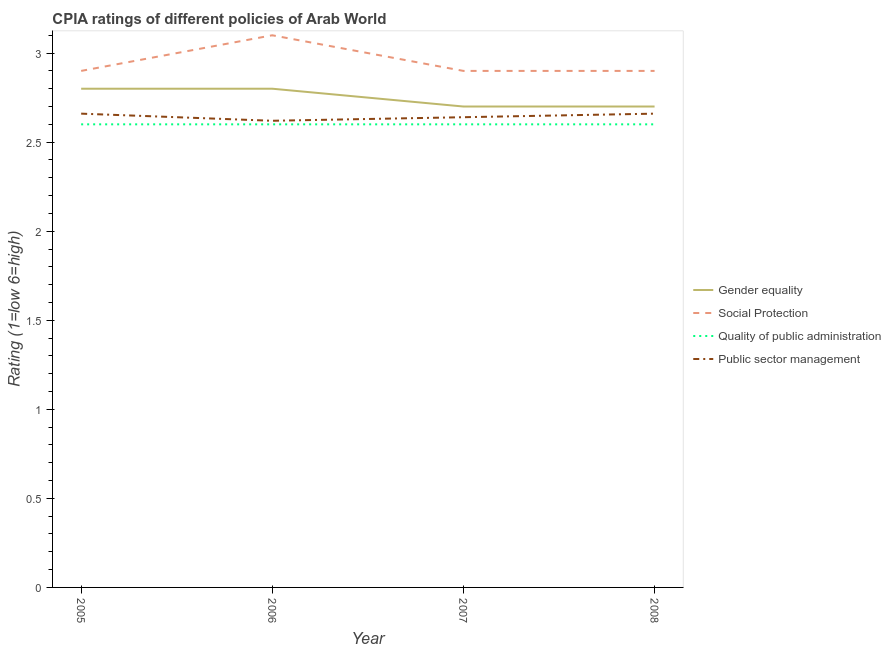Does the line corresponding to cpia rating of public sector management intersect with the line corresponding to cpia rating of gender equality?
Offer a terse response. No. What is the cpia rating of public sector management in 2005?
Keep it short and to the point. 2.66. Across all years, what is the minimum cpia rating of quality of public administration?
Your response must be concise. 2.6. In which year was the cpia rating of quality of public administration minimum?
Your answer should be very brief. 2005. What is the difference between the cpia rating of quality of public administration in 2006 and that in 2007?
Offer a very short reply. 0. What is the difference between the cpia rating of gender equality in 2007 and the cpia rating of quality of public administration in 2008?
Ensure brevity in your answer.  0.1. What is the average cpia rating of gender equality per year?
Your answer should be very brief. 2.75. In the year 2007, what is the difference between the cpia rating of gender equality and cpia rating of public sector management?
Offer a terse response. 0.06. What is the ratio of the cpia rating of gender equality in 2005 to that in 2008?
Your response must be concise. 1.04. What is the difference between the highest and the second highest cpia rating of social protection?
Provide a succinct answer. 0.2. What is the difference between the highest and the lowest cpia rating of gender equality?
Provide a succinct answer. 0.1. In how many years, is the cpia rating of gender equality greater than the average cpia rating of gender equality taken over all years?
Keep it short and to the point. 2. Is it the case that in every year, the sum of the cpia rating of quality of public administration and cpia rating of gender equality is greater than the sum of cpia rating of public sector management and cpia rating of social protection?
Your answer should be very brief. No. Is the cpia rating of gender equality strictly greater than the cpia rating of public sector management over the years?
Your response must be concise. Yes. What is the difference between two consecutive major ticks on the Y-axis?
Your response must be concise. 0.5. Does the graph contain any zero values?
Keep it short and to the point. No. Does the graph contain grids?
Your answer should be compact. No. How are the legend labels stacked?
Give a very brief answer. Vertical. What is the title of the graph?
Offer a terse response. CPIA ratings of different policies of Arab World. What is the label or title of the X-axis?
Make the answer very short. Year. What is the Rating (1=low 6=high) in Gender equality in 2005?
Provide a succinct answer. 2.8. What is the Rating (1=low 6=high) in Social Protection in 2005?
Your answer should be compact. 2.9. What is the Rating (1=low 6=high) of Public sector management in 2005?
Your answer should be very brief. 2.66. What is the Rating (1=low 6=high) of Gender equality in 2006?
Give a very brief answer. 2.8. What is the Rating (1=low 6=high) of Social Protection in 2006?
Offer a very short reply. 3.1. What is the Rating (1=low 6=high) of Quality of public administration in 2006?
Make the answer very short. 2.6. What is the Rating (1=low 6=high) in Public sector management in 2006?
Your response must be concise. 2.62. What is the Rating (1=low 6=high) of Gender equality in 2007?
Provide a succinct answer. 2.7. What is the Rating (1=low 6=high) of Social Protection in 2007?
Provide a succinct answer. 2.9. What is the Rating (1=low 6=high) of Quality of public administration in 2007?
Ensure brevity in your answer.  2.6. What is the Rating (1=low 6=high) in Public sector management in 2007?
Offer a terse response. 2.64. What is the Rating (1=low 6=high) of Public sector management in 2008?
Keep it short and to the point. 2.66. Across all years, what is the maximum Rating (1=low 6=high) of Social Protection?
Offer a very short reply. 3.1. Across all years, what is the maximum Rating (1=low 6=high) in Quality of public administration?
Give a very brief answer. 2.6. Across all years, what is the maximum Rating (1=low 6=high) of Public sector management?
Offer a terse response. 2.66. Across all years, what is the minimum Rating (1=low 6=high) in Gender equality?
Provide a succinct answer. 2.7. Across all years, what is the minimum Rating (1=low 6=high) of Social Protection?
Keep it short and to the point. 2.9. Across all years, what is the minimum Rating (1=low 6=high) of Quality of public administration?
Make the answer very short. 2.6. Across all years, what is the minimum Rating (1=low 6=high) of Public sector management?
Keep it short and to the point. 2.62. What is the total Rating (1=low 6=high) of Gender equality in the graph?
Ensure brevity in your answer.  11. What is the total Rating (1=low 6=high) in Social Protection in the graph?
Your answer should be compact. 11.8. What is the total Rating (1=low 6=high) of Public sector management in the graph?
Offer a terse response. 10.58. What is the difference between the Rating (1=low 6=high) in Public sector management in 2005 and that in 2006?
Provide a short and direct response. 0.04. What is the difference between the Rating (1=low 6=high) in Social Protection in 2005 and that in 2007?
Make the answer very short. 0. What is the difference between the Rating (1=low 6=high) in Quality of public administration in 2005 and that in 2007?
Your answer should be compact. 0. What is the difference between the Rating (1=low 6=high) of Public sector management in 2005 and that in 2007?
Keep it short and to the point. 0.02. What is the difference between the Rating (1=low 6=high) of Social Protection in 2005 and that in 2008?
Keep it short and to the point. 0. What is the difference between the Rating (1=low 6=high) in Quality of public administration in 2005 and that in 2008?
Provide a succinct answer. 0. What is the difference between the Rating (1=low 6=high) in Gender equality in 2006 and that in 2007?
Keep it short and to the point. 0.1. What is the difference between the Rating (1=low 6=high) in Social Protection in 2006 and that in 2007?
Offer a very short reply. 0.2. What is the difference between the Rating (1=low 6=high) of Public sector management in 2006 and that in 2007?
Make the answer very short. -0.02. What is the difference between the Rating (1=low 6=high) of Social Protection in 2006 and that in 2008?
Give a very brief answer. 0.2. What is the difference between the Rating (1=low 6=high) of Quality of public administration in 2006 and that in 2008?
Ensure brevity in your answer.  0. What is the difference between the Rating (1=low 6=high) of Public sector management in 2006 and that in 2008?
Offer a very short reply. -0.04. What is the difference between the Rating (1=low 6=high) of Social Protection in 2007 and that in 2008?
Make the answer very short. 0. What is the difference between the Rating (1=low 6=high) in Public sector management in 2007 and that in 2008?
Give a very brief answer. -0.02. What is the difference between the Rating (1=low 6=high) in Gender equality in 2005 and the Rating (1=low 6=high) in Public sector management in 2006?
Offer a very short reply. 0.18. What is the difference between the Rating (1=low 6=high) in Social Protection in 2005 and the Rating (1=low 6=high) in Quality of public administration in 2006?
Keep it short and to the point. 0.3. What is the difference between the Rating (1=low 6=high) in Social Protection in 2005 and the Rating (1=low 6=high) in Public sector management in 2006?
Offer a terse response. 0.28. What is the difference between the Rating (1=low 6=high) in Quality of public administration in 2005 and the Rating (1=low 6=high) in Public sector management in 2006?
Make the answer very short. -0.02. What is the difference between the Rating (1=low 6=high) of Gender equality in 2005 and the Rating (1=low 6=high) of Quality of public administration in 2007?
Your answer should be compact. 0.2. What is the difference between the Rating (1=low 6=high) in Gender equality in 2005 and the Rating (1=low 6=high) in Public sector management in 2007?
Provide a short and direct response. 0.16. What is the difference between the Rating (1=low 6=high) in Social Protection in 2005 and the Rating (1=low 6=high) in Quality of public administration in 2007?
Give a very brief answer. 0.3. What is the difference between the Rating (1=low 6=high) of Social Protection in 2005 and the Rating (1=low 6=high) of Public sector management in 2007?
Give a very brief answer. 0.26. What is the difference between the Rating (1=low 6=high) in Quality of public administration in 2005 and the Rating (1=low 6=high) in Public sector management in 2007?
Provide a succinct answer. -0.04. What is the difference between the Rating (1=low 6=high) in Gender equality in 2005 and the Rating (1=low 6=high) in Quality of public administration in 2008?
Make the answer very short. 0.2. What is the difference between the Rating (1=low 6=high) of Gender equality in 2005 and the Rating (1=low 6=high) of Public sector management in 2008?
Offer a terse response. 0.14. What is the difference between the Rating (1=low 6=high) of Social Protection in 2005 and the Rating (1=low 6=high) of Quality of public administration in 2008?
Keep it short and to the point. 0.3. What is the difference between the Rating (1=low 6=high) in Social Protection in 2005 and the Rating (1=low 6=high) in Public sector management in 2008?
Ensure brevity in your answer.  0.24. What is the difference between the Rating (1=low 6=high) of Quality of public administration in 2005 and the Rating (1=low 6=high) of Public sector management in 2008?
Provide a short and direct response. -0.06. What is the difference between the Rating (1=low 6=high) of Gender equality in 2006 and the Rating (1=low 6=high) of Public sector management in 2007?
Your response must be concise. 0.16. What is the difference between the Rating (1=low 6=high) in Social Protection in 2006 and the Rating (1=low 6=high) in Public sector management in 2007?
Offer a terse response. 0.46. What is the difference between the Rating (1=low 6=high) of Quality of public administration in 2006 and the Rating (1=low 6=high) of Public sector management in 2007?
Your response must be concise. -0.04. What is the difference between the Rating (1=low 6=high) in Gender equality in 2006 and the Rating (1=low 6=high) in Public sector management in 2008?
Make the answer very short. 0.14. What is the difference between the Rating (1=low 6=high) of Social Protection in 2006 and the Rating (1=low 6=high) of Quality of public administration in 2008?
Provide a succinct answer. 0.5. What is the difference between the Rating (1=low 6=high) in Social Protection in 2006 and the Rating (1=low 6=high) in Public sector management in 2008?
Keep it short and to the point. 0.44. What is the difference between the Rating (1=low 6=high) of Quality of public administration in 2006 and the Rating (1=low 6=high) of Public sector management in 2008?
Give a very brief answer. -0.06. What is the difference between the Rating (1=low 6=high) in Gender equality in 2007 and the Rating (1=low 6=high) in Quality of public administration in 2008?
Offer a very short reply. 0.1. What is the difference between the Rating (1=low 6=high) in Gender equality in 2007 and the Rating (1=low 6=high) in Public sector management in 2008?
Your answer should be compact. 0.04. What is the difference between the Rating (1=low 6=high) of Social Protection in 2007 and the Rating (1=low 6=high) of Public sector management in 2008?
Provide a succinct answer. 0.24. What is the difference between the Rating (1=low 6=high) of Quality of public administration in 2007 and the Rating (1=low 6=high) of Public sector management in 2008?
Keep it short and to the point. -0.06. What is the average Rating (1=low 6=high) of Gender equality per year?
Give a very brief answer. 2.75. What is the average Rating (1=low 6=high) in Social Protection per year?
Your answer should be very brief. 2.95. What is the average Rating (1=low 6=high) in Public sector management per year?
Your answer should be compact. 2.65. In the year 2005, what is the difference between the Rating (1=low 6=high) in Gender equality and Rating (1=low 6=high) in Quality of public administration?
Provide a succinct answer. 0.2. In the year 2005, what is the difference between the Rating (1=low 6=high) in Gender equality and Rating (1=low 6=high) in Public sector management?
Provide a short and direct response. 0.14. In the year 2005, what is the difference between the Rating (1=low 6=high) in Social Protection and Rating (1=low 6=high) in Quality of public administration?
Your answer should be very brief. 0.3. In the year 2005, what is the difference between the Rating (1=low 6=high) in Social Protection and Rating (1=low 6=high) in Public sector management?
Your response must be concise. 0.24. In the year 2005, what is the difference between the Rating (1=low 6=high) of Quality of public administration and Rating (1=low 6=high) of Public sector management?
Give a very brief answer. -0.06. In the year 2006, what is the difference between the Rating (1=low 6=high) of Gender equality and Rating (1=low 6=high) of Social Protection?
Keep it short and to the point. -0.3. In the year 2006, what is the difference between the Rating (1=low 6=high) in Gender equality and Rating (1=low 6=high) in Quality of public administration?
Offer a terse response. 0.2. In the year 2006, what is the difference between the Rating (1=low 6=high) in Gender equality and Rating (1=low 6=high) in Public sector management?
Offer a very short reply. 0.18. In the year 2006, what is the difference between the Rating (1=low 6=high) of Social Protection and Rating (1=low 6=high) of Public sector management?
Your answer should be very brief. 0.48. In the year 2006, what is the difference between the Rating (1=low 6=high) of Quality of public administration and Rating (1=low 6=high) of Public sector management?
Your response must be concise. -0.02. In the year 2007, what is the difference between the Rating (1=low 6=high) in Gender equality and Rating (1=low 6=high) in Social Protection?
Your answer should be very brief. -0.2. In the year 2007, what is the difference between the Rating (1=low 6=high) of Gender equality and Rating (1=low 6=high) of Quality of public administration?
Your answer should be compact. 0.1. In the year 2007, what is the difference between the Rating (1=low 6=high) in Social Protection and Rating (1=low 6=high) in Quality of public administration?
Offer a terse response. 0.3. In the year 2007, what is the difference between the Rating (1=low 6=high) of Social Protection and Rating (1=low 6=high) of Public sector management?
Make the answer very short. 0.26. In the year 2007, what is the difference between the Rating (1=low 6=high) in Quality of public administration and Rating (1=low 6=high) in Public sector management?
Offer a very short reply. -0.04. In the year 2008, what is the difference between the Rating (1=low 6=high) of Gender equality and Rating (1=low 6=high) of Social Protection?
Offer a terse response. -0.2. In the year 2008, what is the difference between the Rating (1=low 6=high) of Gender equality and Rating (1=low 6=high) of Quality of public administration?
Your answer should be very brief. 0.1. In the year 2008, what is the difference between the Rating (1=low 6=high) of Social Protection and Rating (1=low 6=high) of Quality of public administration?
Make the answer very short. 0.3. In the year 2008, what is the difference between the Rating (1=low 6=high) of Social Protection and Rating (1=low 6=high) of Public sector management?
Make the answer very short. 0.24. In the year 2008, what is the difference between the Rating (1=low 6=high) of Quality of public administration and Rating (1=low 6=high) of Public sector management?
Provide a succinct answer. -0.06. What is the ratio of the Rating (1=low 6=high) in Social Protection in 2005 to that in 2006?
Give a very brief answer. 0.94. What is the ratio of the Rating (1=low 6=high) of Public sector management in 2005 to that in 2006?
Provide a short and direct response. 1.02. What is the ratio of the Rating (1=low 6=high) in Gender equality in 2005 to that in 2007?
Make the answer very short. 1.04. What is the ratio of the Rating (1=low 6=high) in Social Protection in 2005 to that in 2007?
Your answer should be very brief. 1. What is the ratio of the Rating (1=low 6=high) of Public sector management in 2005 to that in 2007?
Your answer should be compact. 1.01. What is the ratio of the Rating (1=low 6=high) of Quality of public administration in 2005 to that in 2008?
Make the answer very short. 1. What is the ratio of the Rating (1=low 6=high) in Public sector management in 2005 to that in 2008?
Offer a very short reply. 1. What is the ratio of the Rating (1=low 6=high) in Social Protection in 2006 to that in 2007?
Provide a short and direct response. 1.07. What is the ratio of the Rating (1=low 6=high) in Gender equality in 2006 to that in 2008?
Provide a succinct answer. 1.04. What is the ratio of the Rating (1=low 6=high) of Social Protection in 2006 to that in 2008?
Ensure brevity in your answer.  1.07. What is the ratio of the Rating (1=low 6=high) of Social Protection in 2007 to that in 2008?
Give a very brief answer. 1. What is the ratio of the Rating (1=low 6=high) in Quality of public administration in 2007 to that in 2008?
Offer a very short reply. 1. What is the difference between the highest and the second highest Rating (1=low 6=high) of Gender equality?
Offer a very short reply. 0. What is the difference between the highest and the second highest Rating (1=low 6=high) in Quality of public administration?
Ensure brevity in your answer.  0. What is the difference between the highest and the second highest Rating (1=low 6=high) in Public sector management?
Your answer should be very brief. 0. What is the difference between the highest and the lowest Rating (1=low 6=high) in Gender equality?
Offer a terse response. 0.1. What is the difference between the highest and the lowest Rating (1=low 6=high) in Social Protection?
Your answer should be very brief. 0.2. 